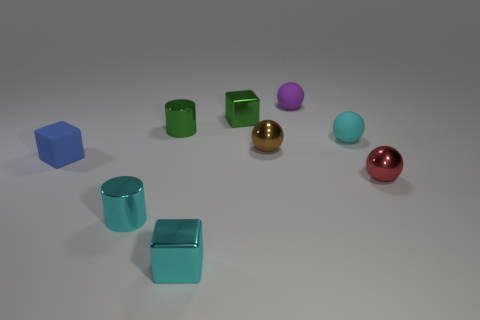Subtract all matte blocks. How many blocks are left? 2 Subtract 1 cylinders. How many cylinders are left? 1 Subtract all green balls. How many brown cubes are left? 0 Subtract all tiny blue rubber things. Subtract all cyan metal cylinders. How many objects are left? 7 Add 9 purple spheres. How many purple spheres are left? 10 Add 7 rubber cubes. How many rubber cubes exist? 8 Subtract all green cylinders. How many cylinders are left? 1 Subtract 1 cyan blocks. How many objects are left? 8 Subtract all cylinders. How many objects are left? 7 Subtract all purple cylinders. Subtract all purple cubes. How many cylinders are left? 2 